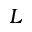<formula> <loc_0><loc_0><loc_500><loc_500>L</formula> 